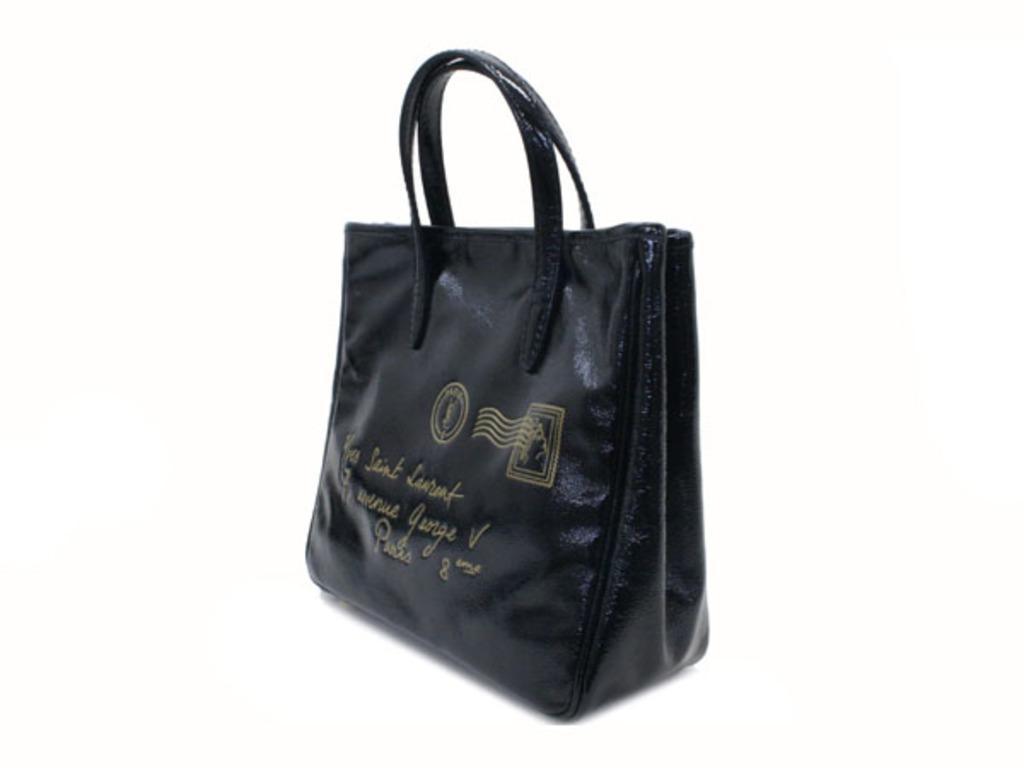Please provide a concise description of this image. This is a leather handbag. 